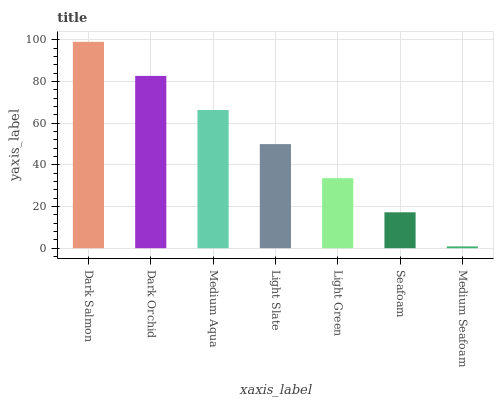Is Dark Orchid the minimum?
Answer yes or no. No. Is Dark Orchid the maximum?
Answer yes or no. No. Is Dark Salmon greater than Dark Orchid?
Answer yes or no. Yes. Is Dark Orchid less than Dark Salmon?
Answer yes or no. Yes. Is Dark Orchid greater than Dark Salmon?
Answer yes or no. No. Is Dark Salmon less than Dark Orchid?
Answer yes or no. No. Is Light Slate the high median?
Answer yes or no. Yes. Is Light Slate the low median?
Answer yes or no. Yes. Is Medium Aqua the high median?
Answer yes or no. No. Is Dark Orchid the low median?
Answer yes or no. No. 